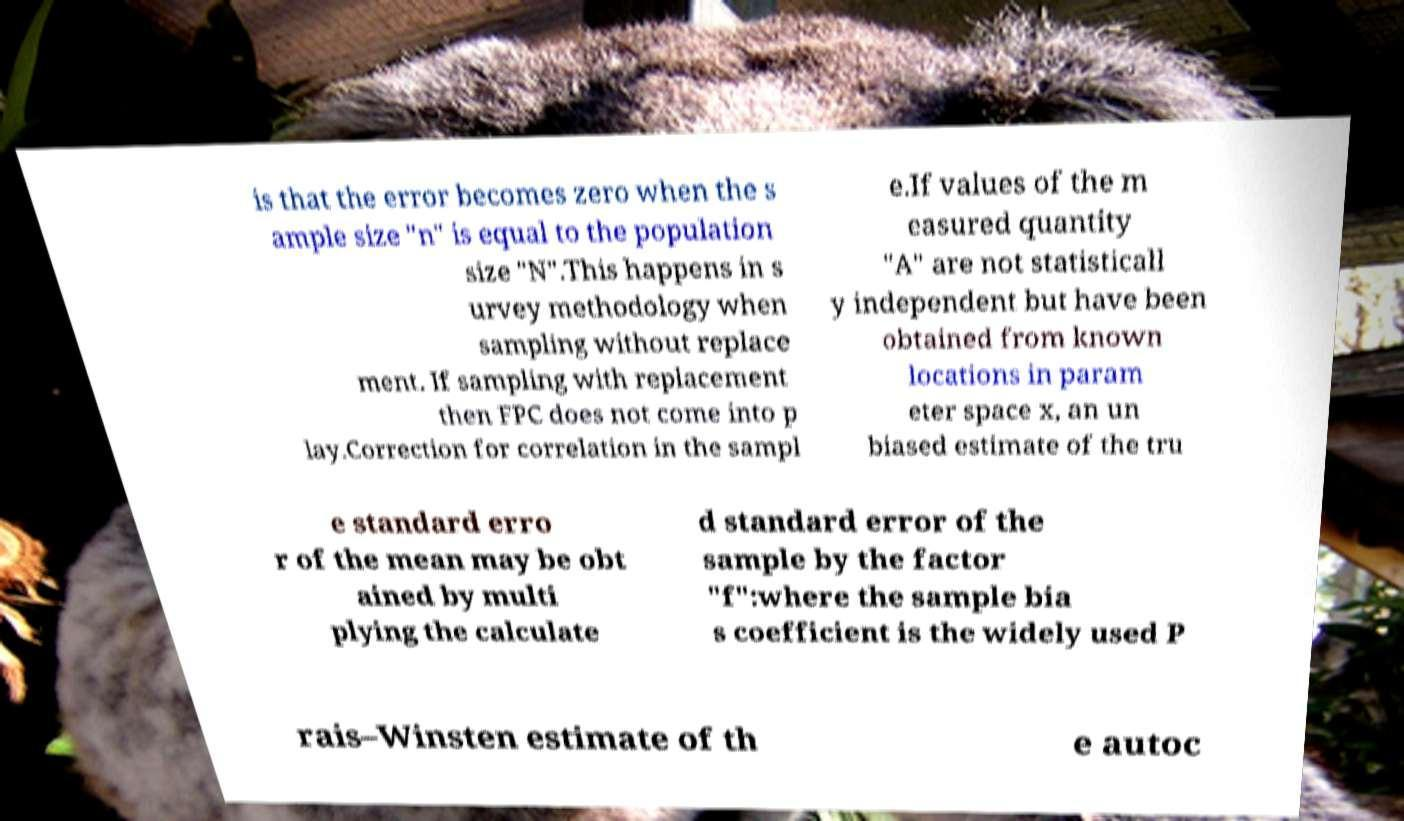Could you extract and type out the text from this image? is that the error becomes zero when the s ample size "n" is equal to the population size "N".This happens in s urvey methodology when sampling without replace ment. If sampling with replacement then FPC does not come into p lay.Correction for correlation in the sampl e.If values of the m easured quantity "A" are not statisticall y independent but have been obtained from known locations in param eter space x, an un biased estimate of the tru e standard erro r of the mean may be obt ained by multi plying the calculate d standard error of the sample by the factor "f":where the sample bia s coefficient is the widely used P rais–Winsten estimate of th e autoc 